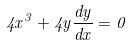<formula> <loc_0><loc_0><loc_500><loc_500>4 x ^ { 3 } + 4 y \frac { d y } { d x } = 0</formula> 